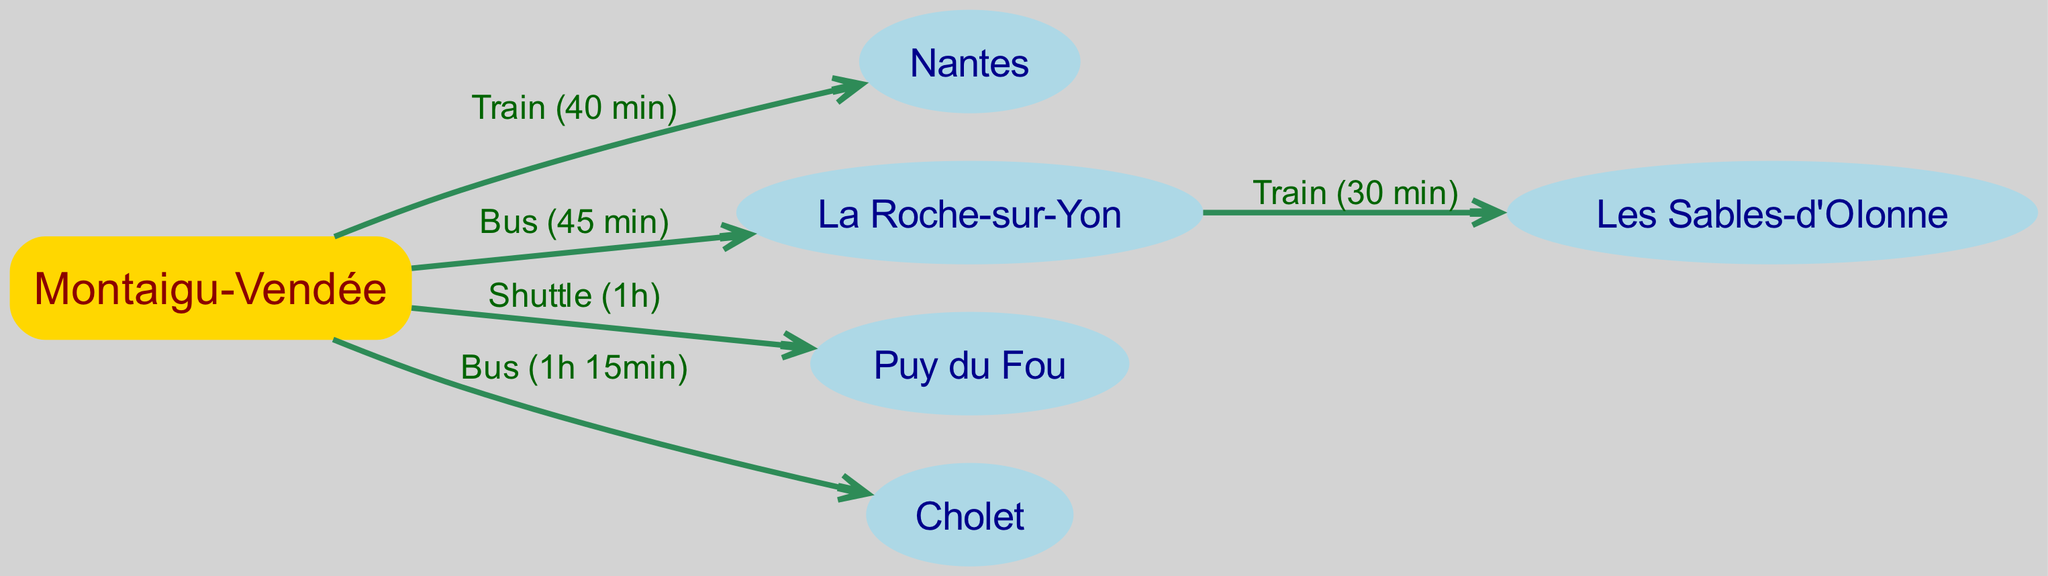What is the transportation mode from Montaigu-Vendée to Nantes? The edge connecting Montaigu-Vendée to Nantes has the label "Train (40 min)," which indicates the mode of transport between these two locations.
Answer: Train How long does it take to travel from Montaigu-Vendée to La Roche-sur-Yon? The edge identified between Montaigu-Vendée and La Roche-sur-Yon states "Bus (45 min)," which reveals the duration of the journey.
Answer: 45 min Which city can be reached by train from La Roche-sur-Yon? There is an edge leading from La Roche-sur-Yon to Les Sables-d'Olonne labeled "Train (30 min)," indicating that this city is accessible by train from La Roche-sur-Yon.
Answer: Les Sables-d'Olonne What is the longest travel time on the routes starting from Montaigu-Vendée? By examining the edges, the route from Montaigu-Vendée to Cholet is labeled "Bus (1h 15min)," which is longer than all other connections starting from Montaigu-Vendée.
Answer: 1h 15min How many total nodes are present in the diagram? The diagram lists six unique nodes that represent the key locations: Montaigu-Vendée, Nantes, La Roche-sur-Yon, Puy du Fou, Cholet, and Les Sables-d'Olonne. Counting these gives us the total number of nodes.
Answer: 6 Which destination requires a shuttle from Montaigu-Vendée? A closer analysis of the edges shows that Montaigu-Vendée connects to Puy du Fou via a "Shuttle (1h)." Thus, Puy du Fou is the destination requiring this specific mode of transport.
Answer: Puy du Fou Is there a direct bus route from Montaigu-Vendée to Cholet? The edge between Montaigu-Vendée and Cholet has a label indicating "Bus (1h 15min)," confirming there is indeed a direct bus route to this destination.
Answer: Yes What is the name of the city connected to Montaigu-Vendée that has the shortest travel time? Among the edges originating from Montaigu-Vendée, the shortest travel time is to Nantes, labeled "Train (40 min)." Therefore, Nantes is the city with the shortest connection from Montaigu-Vendée.
Answer: Nantes How many edges are depicted in the diagram? By reviewing the listed connections, there are five edges that represent the different transportation routes, showcasing the movement between associated nodes.
Answer: 5 